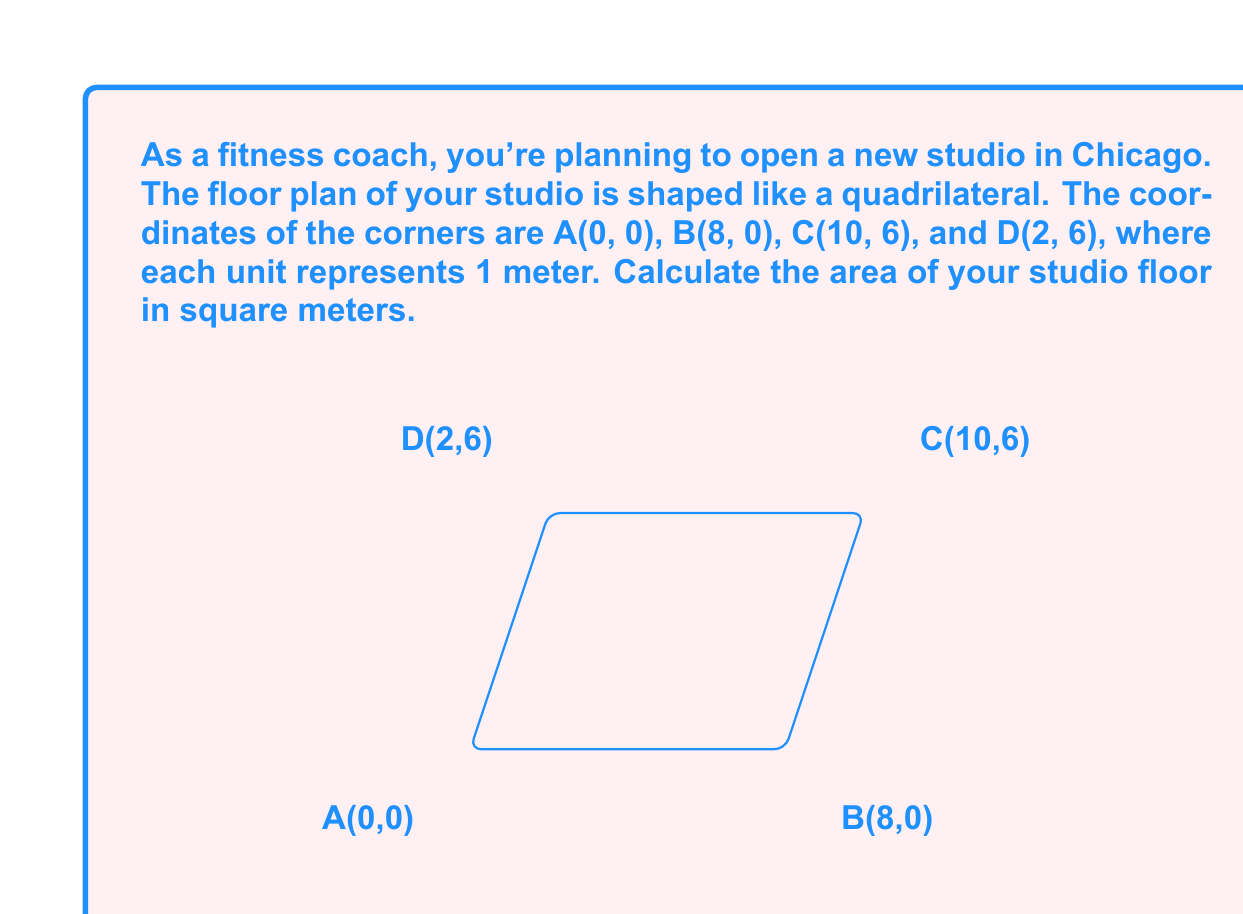Help me with this question. To find the area of this quadrilateral, we can split it into two triangles and use the formula for the area of a triangle using coordinates.

1) Let's split the quadrilateral into triangles ABC and ACD.

2) The formula for the area of a triangle with vertices $(x_1, y_1)$, $(x_2, y_2)$, and $(x_3, y_3)$ is:

   $$\text{Area} = \frac{1}{2}|x_1(y_2 - y_3) + x_2(y_3 - y_1) + x_3(y_1 - y_2)|$$

3) For triangle ABC:
   $$(x_1, y_1) = (0, 0), (x_2, y_2) = (8, 0), (x_3, y_3) = (10, 6)$$
   
   $$\text{Area}_{\text{ABC}} = \frac{1}{2}|0(0 - 6) + 8(6 - 0) + 10(0 - 0)| = \frac{1}{2}|0 + 48 + 0| = 24$$

4) For triangle ACD:
   $$(x_1, y_1) = (0, 0), (x_2, y_2) = (10, 6), (x_3, y_3) = (2, 6)$$
   
   $$\text{Area}_{\text{ACD}} = \frac{1}{2}|0(6 - 6) + 10(6 - 0) + 2(0 - 6)| = \frac{1}{2}|0 + 60 - 12| = 24$$

5) The total area is the sum of these two triangles:

   $$\text{Total Area} = \text{Area}_{\text{ABC}} + \text{Area}_{\text{ACD}} = 24 + 24 = 48$$

Therefore, the area of your fitness studio floor is 48 square meters.
Answer: 48 m² 